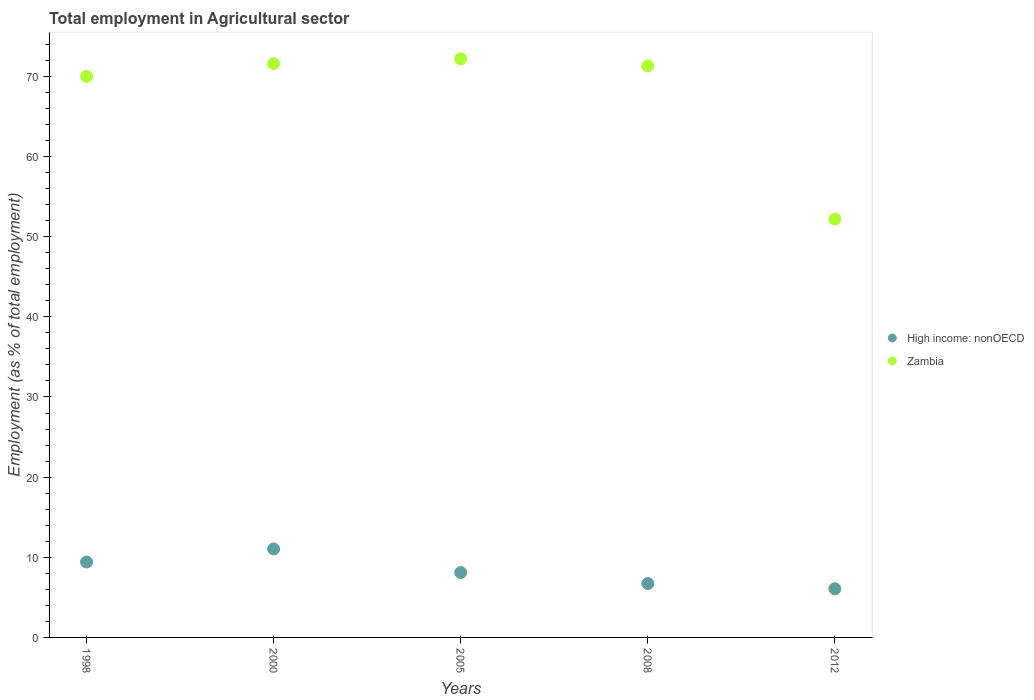Is the number of dotlines equal to the number of legend labels?
Your response must be concise. Yes. What is the employment in agricultural sector in Zambia in 2008?
Your answer should be compact. 71.3. Across all years, what is the maximum employment in agricultural sector in Zambia?
Your answer should be very brief. 72.2. Across all years, what is the minimum employment in agricultural sector in High income: nonOECD?
Provide a short and direct response. 6.07. In which year was the employment in agricultural sector in High income: nonOECD maximum?
Ensure brevity in your answer.  2000. In which year was the employment in agricultural sector in High income: nonOECD minimum?
Your answer should be compact. 2012. What is the total employment in agricultural sector in High income: nonOECD in the graph?
Offer a terse response. 41.33. What is the difference between the employment in agricultural sector in Zambia in 2000 and that in 2012?
Offer a terse response. 19.4. What is the difference between the employment in agricultural sector in High income: nonOECD in 2000 and the employment in agricultural sector in Zambia in 2005?
Your answer should be compact. -61.16. What is the average employment in agricultural sector in Zambia per year?
Keep it short and to the point. 67.46. In the year 2008, what is the difference between the employment in agricultural sector in Zambia and employment in agricultural sector in High income: nonOECD?
Your response must be concise. 64.58. What is the ratio of the employment in agricultural sector in High income: nonOECD in 2000 to that in 2012?
Offer a terse response. 1.82. Is the employment in agricultural sector in High income: nonOECD in 1998 less than that in 2012?
Provide a succinct answer. No. What is the difference between the highest and the second highest employment in agricultural sector in High income: nonOECD?
Offer a very short reply. 1.63. What is the difference between the highest and the lowest employment in agricultural sector in Zambia?
Offer a terse response. 20. In how many years, is the employment in agricultural sector in Zambia greater than the average employment in agricultural sector in Zambia taken over all years?
Your answer should be very brief. 4. Is the sum of the employment in agricultural sector in Zambia in 2000 and 2008 greater than the maximum employment in agricultural sector in High income: nonOECD across all years?
Your response must be concise. Yes. Does the employment in agricultural sector in Zambia monotonically increase over the years?
Your response must be concise. No. Is the employment in agricultural sector in High income: nonOECD strictly greater than the employment in agricultural sector in Zambia over the years?
Make the answer very short. No. Are the values on the major ticks of Y-axis written in scientific E-notation?
Give a very brief answer. No. Where does the legend appear in the graph?
Offer a very short reply. Center right. How many legend labels are there?
Your response must be concise. 2. How are the legend labels stacked?
Keep it short and to the point. Vertical. What is the title of the graph?
Make the answer very short. Total employment in Agricultural sector. Does "Uzbekistan" appear as one of the legend labels in the graph?
Your response must be concise. No. What is the label or title of the X-axis?
Give a very brief answer. Years. What is the label or title of the Y-axis?
Offer a very short reply. Employment (as % of total employment). What is the Employment (as % of total employment) in High income: nonOECD in 1998?
Your answer should be very brief. 9.41. What is the Employment (as % of total employment) in Zambia in 1998?
Keep it short and to the point. 70. What is the Employment (as % of total employment) of High income: nonOECD in 2000?
Make the answer very short. 11.04. What is the Employment (as % of total employment) in Zambia in 2000?
Your answer should be very brief. 71.6. What is the Employment (as % of total employment) of High income: nonOECD in 2005?
Offer a terse response. 8.09. What is the Employment (as % of total employment) in Zambia in 2005?
Provide a short and direct response. 72.2. What is the Employment (as % of total employment) of High income: nonOECD in 2008?
Keep it short and to the point. 6.72. What is the Employment (as % of total employment) in Zambia in 2008?
Make the answer very short. 71.3. What is the Employment (as % of total employment) of High income: nonOECD in 2012?
Provide a succinct answer. 6.07. What is the Employment (as % of total employment) of Zambia in 2012?
Provide a succinct answer. 52.2. Across all years, what is the maximum Employment (as % of total employment) in High income: nonOECD?
Your response must be concise. 11.04. Across all years, what is the maximum Employment (as % of total employment) in Zambia?
Offer a terse response. 72.2. Across all years, what is the minimum Employment (as % of total employment) in High income: nonOECD?
Offer a very short reply. 6.07. Across all years, what is the minimum Employment (as % of total employment) in Zambia?
Give a very brief answer. 52.2. What is the total Employment (as % of total employment) of High income: nonOECD in the graph?
Provide a succinct answer. 41.33. What is the total Employment (as % of total employment) in Zambia in the graph?
Offer a very short reply. 337.3. What is the difference between the Employment (as % of total employment) in High income: nonOECD in 1998 and that in 2000?
Give a very brief answer. -1.63. What is the difference between the Employment (as % of total employment) of Zambia in 1998 and that in 2000?
Offer a very short reply. -1.6. What is the difference between the Employment (as % of total employment) of High income: nonOECD in 1998 and that in 2005?
Offer a terse response. 1.32. What is the difference between the Employment (as % of total employment) in High income: nonOECD in 1998 and that in 2008?
Offer a very short reply. 2.69. What is the difference between the Employment (as % of total employment) in High income: nonOECD in 1998 and that in 2012?
Ensure brevity in your answer.  3.34. What is the difference between the Employment (as % of total employment) in High income: nonOECD in 2000 and that in 2005?
Offer a very short reply. 2.95. What is the difference between the Employment (as % of total employment) in Zambia in 2000 and that in 2005?
Offer a terse response. -0.6. What is the difference between the Employment (as % of total employment) in High income: nonOECD in 2000 and that in 2008?
Your response must be concise. 4.32. What is the difference between the Employment (as % of total employment) in Zambia in 2000 and that in 2008?
Offer a very short reply. 0.3. What is the difference between the Employment (as % of total employment) in High income: nonOECD in 2000 and that in 2012?
Give a very brief answer. 4.97. What is the difference between the Employment (as % of total employment) of High income: nonOECD in 2005 and that in 2008?
Make the answer very short. 1.37. What is the difference between the Employment (as % of total employment) in Zambia in 2005 and that in 2008?
Your answer should be very brief. 0.9. What is the difference between the Employment (as % of total employment) in High income: nonOECD in 2005 and that in 2012?
Ensure brevity in your answer.  2.02. What is the difference between the Employment (as % of total employment) in High income: nonOECD in 2008 and that in 2012?
Provide a short and direct response. 0.65. What is the difference between the Employment (as % of total employment) of High income: nonOECD in 1998 and the Employment (as % of total employment) of Zambia in 2000?
Keep it short and to the point. -62.19. What is the difference between the Employment (as % of total employment) of High income: nonOECD in 1998 and the Employment (as % of total employment) of Zambia in 2005?
Give a very brief answer. -62.79. What is the difference between the Employment (as % of total employment) in High income: nonOECD in 1998 and the Employment (as % of total employment) in Zambia in 2008?
Your answer should be very brief. -61.89. What is the difference between the Employment (as % of total employment) in High income: nonOECD in 1998 and the Employment (as % of total employment) in Zambia in 2012?
Keep it short and to the point. -42.79. What is the difference between the Employment (as % of total employment) in High income: nonOECD in 2000 and the Employment (as % of total employment) in Zambia in 2005?
Your answer should be very brief. -61.16. What is the difference between the Employment (as % of total employment) in High income: nonOECD in 2000 and the Employment (as % of total employment) in Zambia in 2008?
Keep it short and to the point. -60.26. What is the difference between the Employment (as % of total employment) of High income: nonOECD in 2000 and the Employment (as % of total employment) of Zambia in 2012?
Give a very brief answer. -41.16. What is the difference between the Employment (as % of total employment) in High income: nonOECD in 2005 and the Employment (as % of total employment) in Zambia in 2008?
Make the answer very short. -63.21. What is the difference between the Employment (as % of total employment) in High income: nonOECD in 2005 and the Employment (as % of total employment) in Zambia in 2012?
Offer a terse response. -44.11. What is the difference between the Employment (as % of total employment) in High income: nonOECD in 2008 and the Employment (as % of total employment) in Zambia in 2012?
Provide a short and direct response. -45.48. What is the average Employment (as % of total employment) of High income: nonOECD per year?
Your answer should be very brief. 8.27. What is the average Employment (as % of total employment) of Zambia per year?
Make the answer very short. 67.46. In the year 1998, what is the difference between the Employment (as % of total employment) of High income: nonOECD and Employment (as % of total employment) of Zambia?
Make the answer very short. -60.59. In the year 2000, what is the difference between the Employment (as % of total employment) of High income: nonOECD and Employment (as % of total employment) of Zambia?
Offer a very short reply. -60.56. In the year 2005, what is the difference between the Employment (as % of total employment) in High income: nonOECD and Employment (as % of total employment) in Zambia?
Give a very brief answer. -64.11. In the year 2008, what is the difference between the Employment (as % of total employment) of High income: nonOECD and Employment (as % of total employment) of Zambia?
Make the answer very short. -64.58. In the year 2012, what is the difference between the Employment (as % of total employment) in High income: nonOECD and Employment (as % of total employment) in Zambia?
Offer a very short reply. -46.13. What is the ratio of the Employment (as % of total employment) of High income: nonOECD in 1998 to that in 2000?
Keep it short and to the point. 0.85. What is the ratio of the Employment (as % of total employment) of Zambia in 1998 to that in 2000?
Your answer should be compact. 0.98. What is the ratio of the Employment (as % of total employment) in High income: nonOECD in 1998 to that in 2005?
Provide a succinct answer. 1.16. What is the ratio of the Employment (as % of total employment) in Zambia in 1998 to that in 2005?
Give a very brief answer. 0.97. What is the ratio of the Employment (as % of total employment) of High income: nonOECD in 1998 to that in 2008?
Give a very brief answer. 1.4. What is the ratio of the Employment (as % of total employment) of Zambia in 1998 to that in 2008?
Your response must be concise. 0.98. What is the ratio of the Employment (as % of total employment) in High income: nonOECD in 1998 to that in 2012?
Offer a very short reply. 1.55. What is the ratio of the Employment (as % of total employment) in Zambia in 1998 to that in 2012?
Give a very brief answer. 1.34. What is the ratio of the Employment (as % of total employment) in High income: nonOECD in 2000 to that in 2005?
Provide a short and direct response. 1.36. What is the ratio of the Employment (as % of total employment) of Zambia in 2000 to that in 2005?
Offer a terse response. 0.99. What is the ratio of the Employment (as % of total employment) of High income: nonOECD in 2000 to that in 2008?
Make the answer very short. 1.64. What is the ratio of the Employment (as % of total employment) in Zambia in 2000 to that in 2008?
Your response must be concise. 1. What is the ratio of the Employment (as % of total employment) of High income: nonOECD in 2000 to that in 2012?
Your answer should be very brief. 1.82. What is the ratio of the Employment (as % of total employment) in Zambia in 2000 to that in 2012?
Keep it short and to the point. 1.37. What is the ratio of the Employment (as % of total employment) in High income: nonOECD in 2005 to that in 2008?
Make the answer very short. 1.2. What is the ratio of the Employment (as % of total employment) in Zambia in 2005 to that in 2008?
Keep it short and to the point. 1.01. What is the ratio of the Employment (as % of total employment) of High income: nonOECD in 2005 to that in 2012?
Offer a terse response. 1.33. What is the ratio of the Employment (as % of total employment) in Zambia in 2005 to that in 2012?
Offer a very short reply. 1.38. What is the ratio of the Employment (as % of total employment) of High income: nonOECD in 2008 to that in 2012?
Make the answer very short. 1.11. What is the ratio of the Employment (as % of total employment) of Zambia in 2008 to that in 2012?
Provide a succinct answer. 1.37. What is the difference between the highest and the second highest Employment (as % of total employment) of High income: nonOECD?
Provide a succinct answer. 1.63. What is the difference between the highest and the second highest Employment (as % of total employment) in Zambia?
Give a very brief answer. 0.6. What is the difference between the highest and the lowest Employment (as % of total employment) in High income: nonOECD?
Provide a short and direct response. 4.97. What is the difference between the highest and the lowest Employment (as % of total employment) in Zambia?
Provide a short and direct response. 20. 